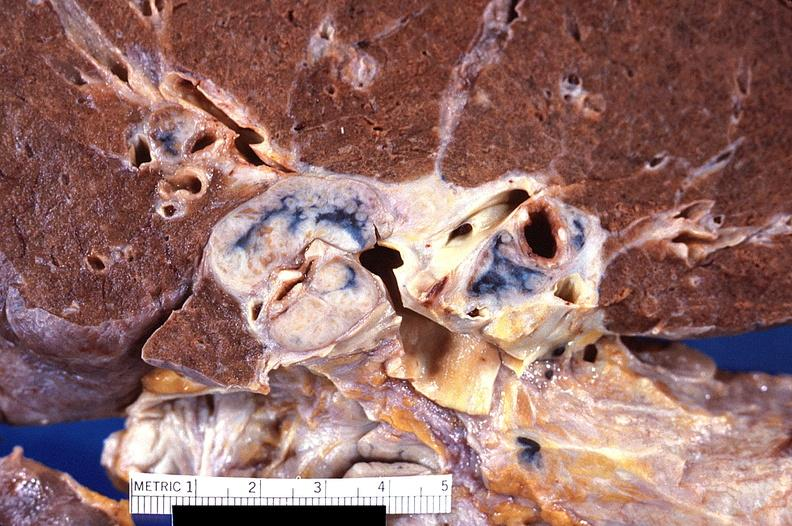what is present?
Answer the question using a single word or phrase. Respiratory 